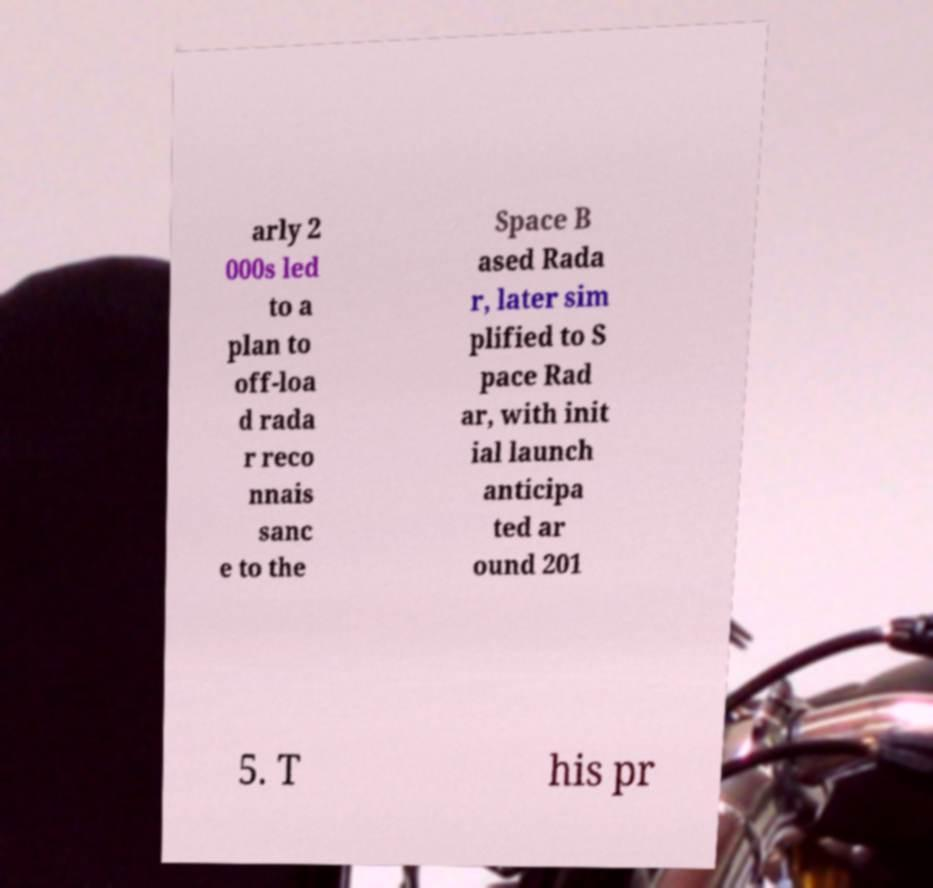I need the written content from this picture converted into text. Can you do that? arly 2 000s led to a plan to off-loa d rada r reco nnais sanc e to the Space B ased Rada r, later sim plified to S pace Rad ar, with init ial launch anticipa ted ar ound 201 5. T his pr 